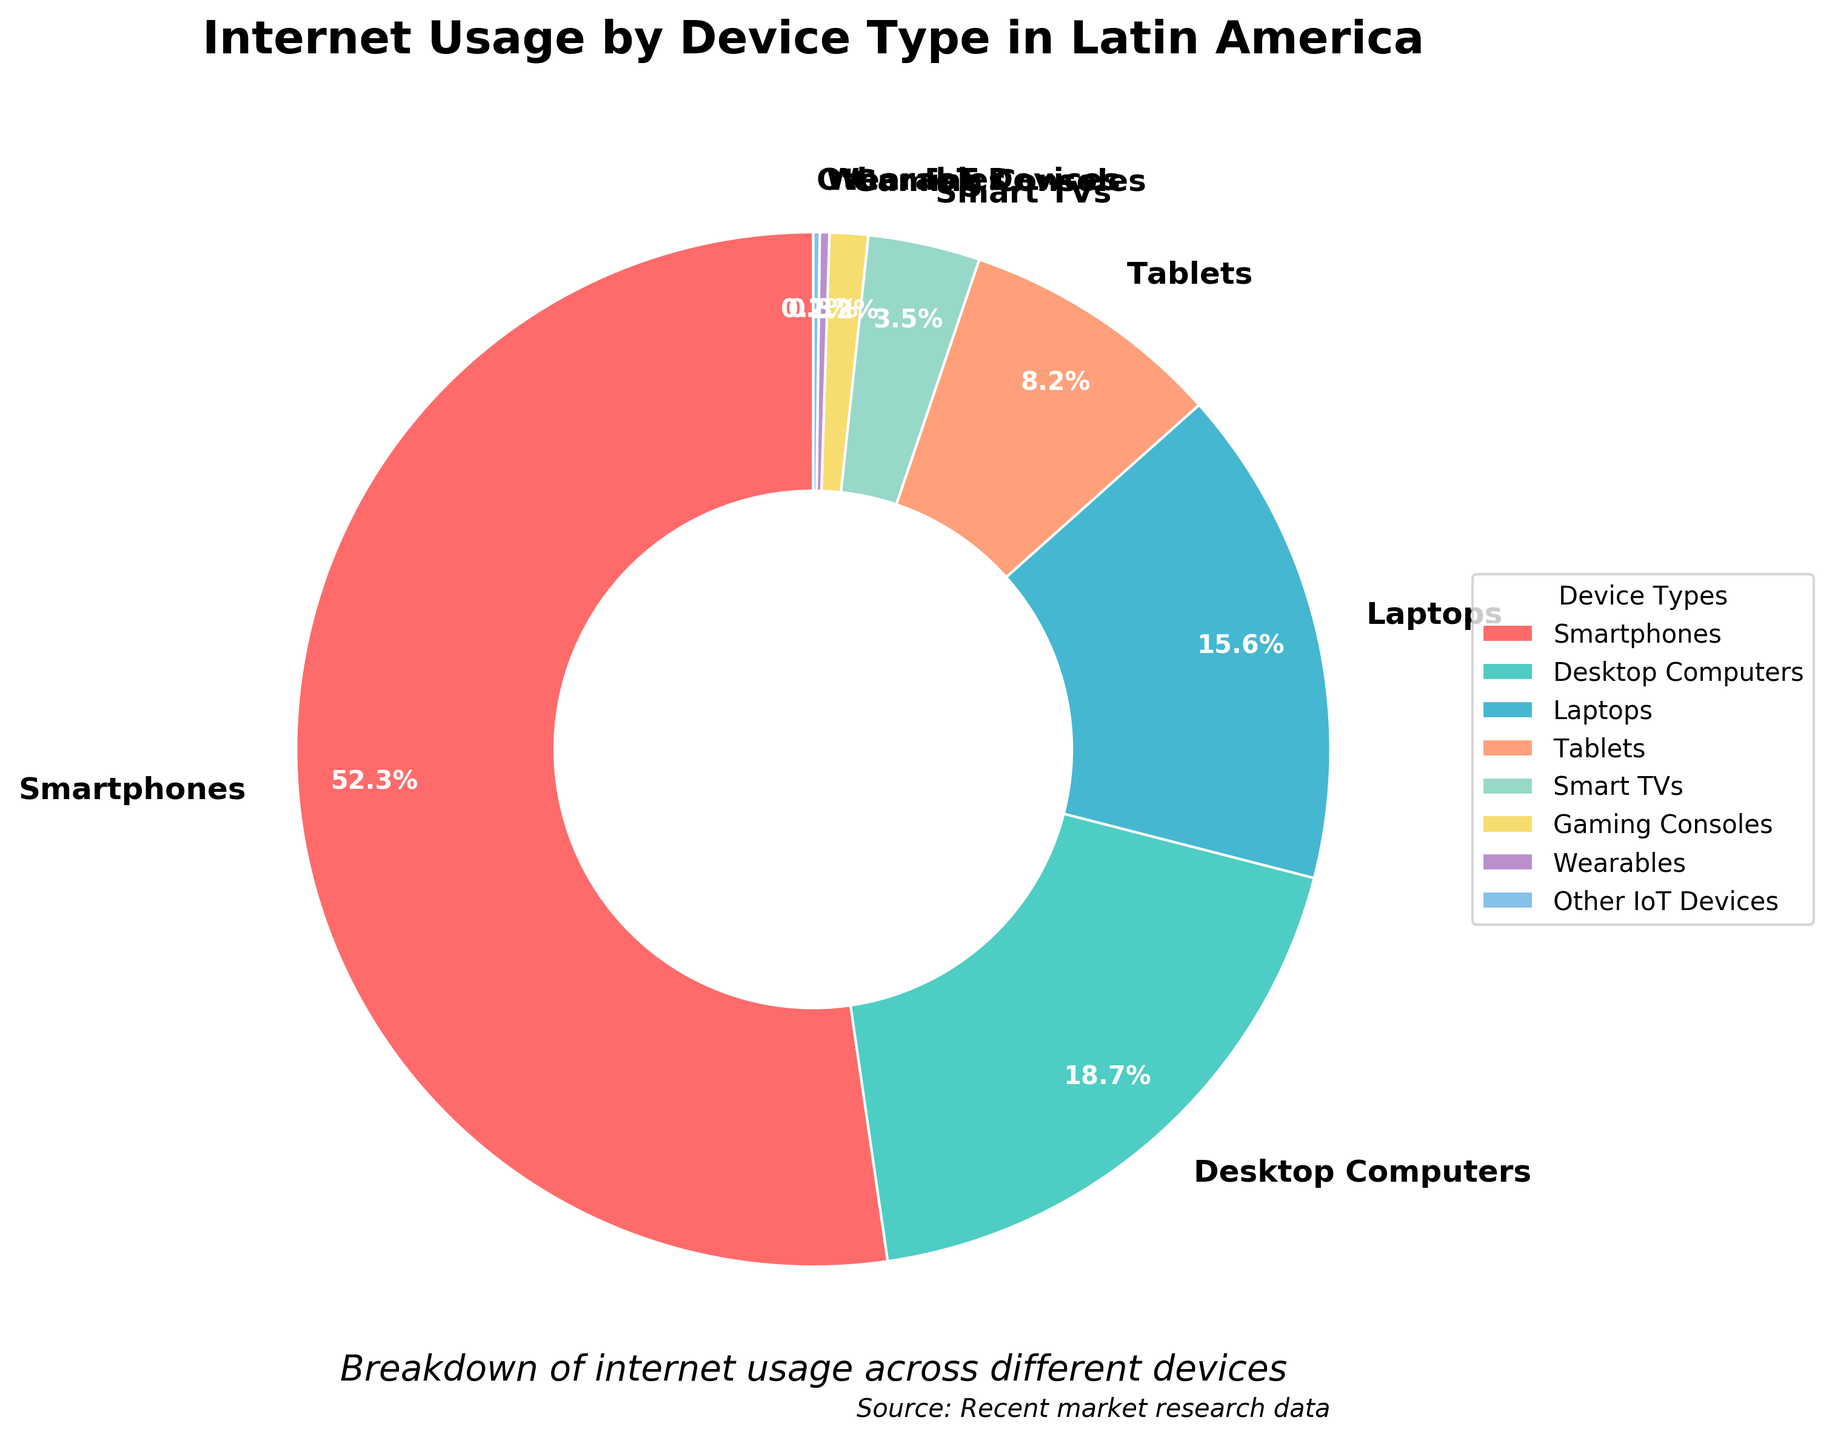What's the percentage of internet usage via Smartphones? The pie chart shows different device types and their respective internet usage percentages. According to the chart, Smartphones have a usage percentage of 52.3%.
Answer: 52.3% Which device type has the least internet usage percentage? The pie chart breaks down internet usage by various device types and the smallest wedge, representing the least percentage, is for Other IoT Devices with 0.2%.
Answer: Other IoT Devices What's the combined percentage of internet usage via Laptops and Tablets? To find the combined percentage, add the individual percentages of Laptops (15.6%) and Tablets (8.2%). So, 15.6% + 8.2% = 23.8%.
Answer: 23.8% Which type of device is used more for internet access, Desktop Computers or Laptops? By comparing the percentages on the pie chart, Desktop Computers have 18.7% while Laptops have 15.6%. Thus, Desktop Computers are used more.
Answer: Desktop Computers What is the percentage difference in internet usage between Smart TVs and Gaming Consoles? To find the difference, subtract the percentage of Gaming Consoles (1.2%) from Smart TVs (3.5%). So, 3.5% - 1.2% = 2.3%.
Answer: 2.3% Does the proportion of internet usage via Wearables exceed 1%? The wedge for Wearables on the pie chart shows a percentage of 0.3%. This is less than 1%.
Answer: No List the device types that have a usage percentage greater than 10%. Checking the pie chart, the device types with more than 10% usage are Smartphones (52.3%), Desktop Computers (18.7%), and Laptops (15.6%).
Answer: Smartphones, Desktop Computers, Laptops What's the total percentage of internet usage represented by smaller devices such as Wearables and Other IoT Devices? Add the percentages of Wearables (0.3%) and Other IoT Devices (0.2%). So, 0.3% + 0.2% = 0.5%.
Answer: 0.5% Is the internet usage of Tablets greater than Smart TVs and Gaming Consoles combined? Add the percentages for Smart TVs (3.5%) and Gaming Consoles (1.2%), which sums to 4.7%. Then compare to Tablets' percentage of 8.2%, which is higher.
Answer: Yes 